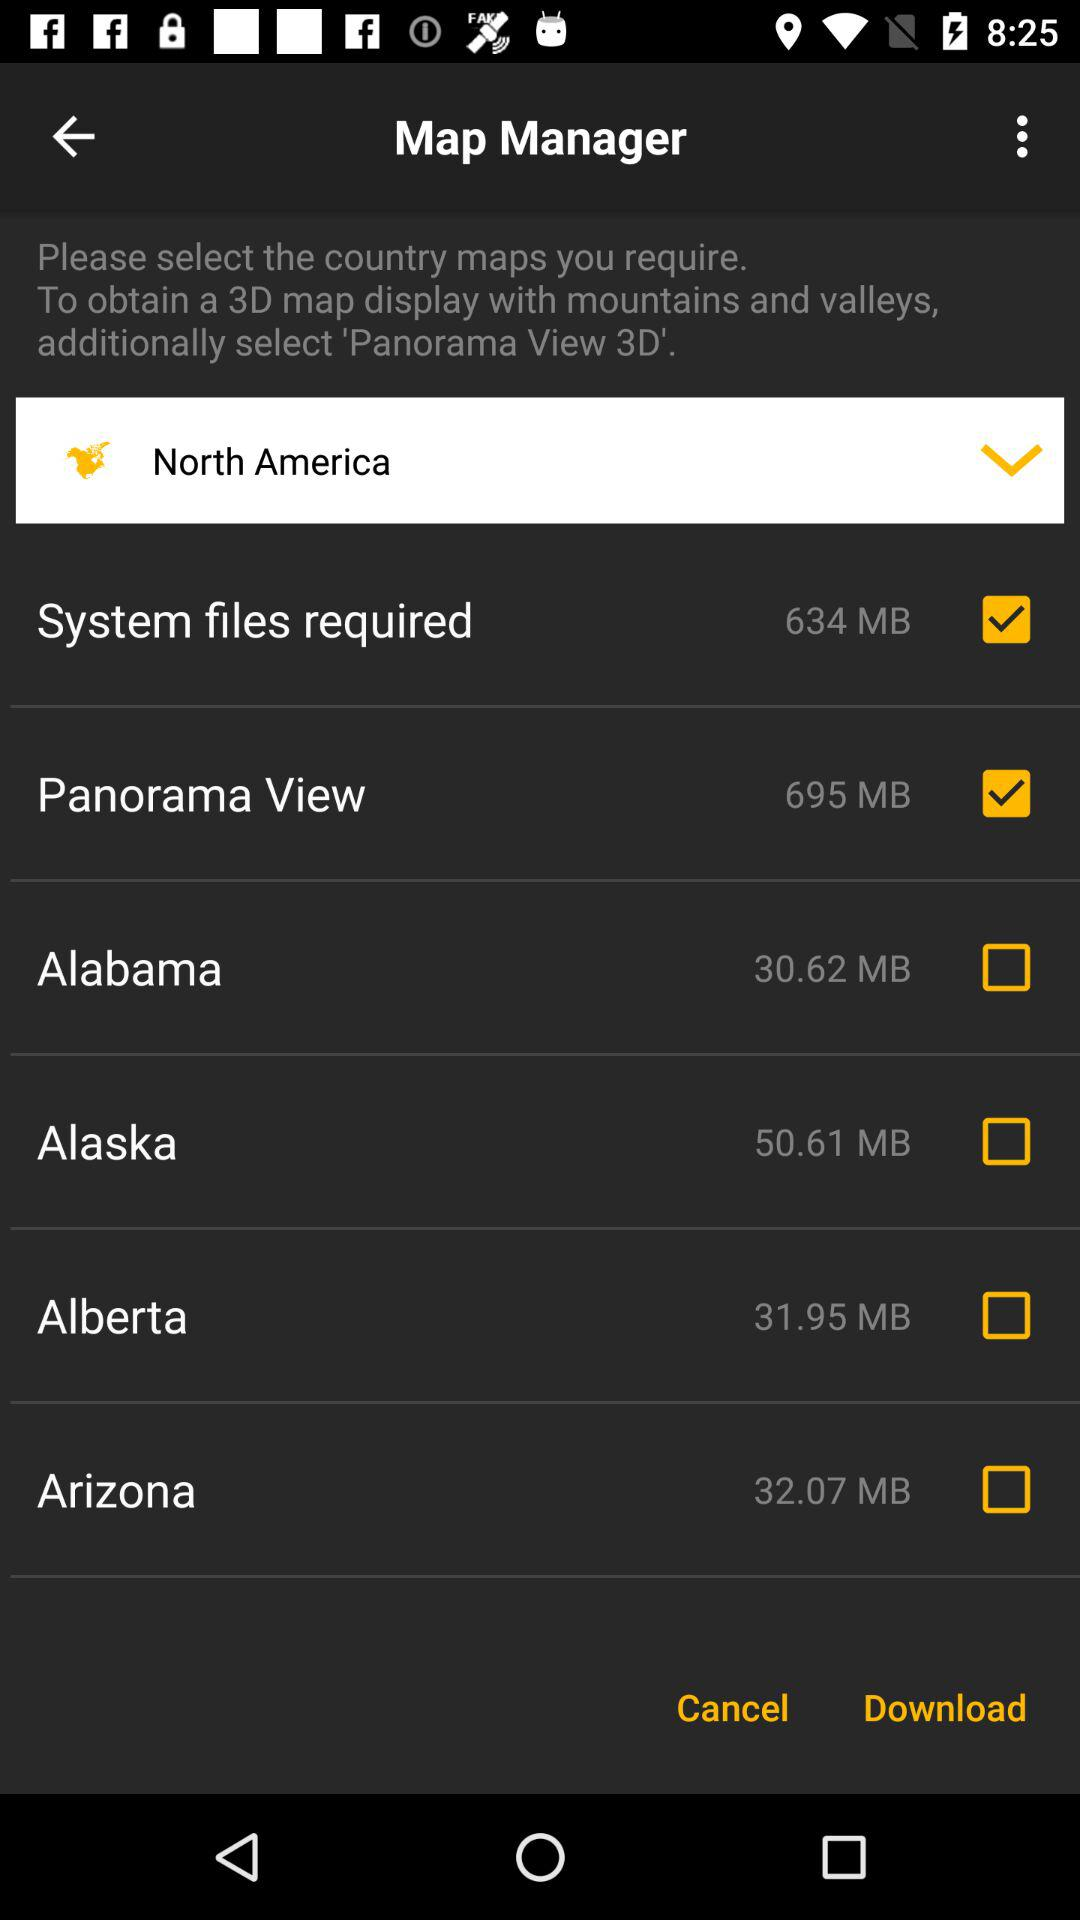What is the name of the application? The name of the application is "Map Manager". 